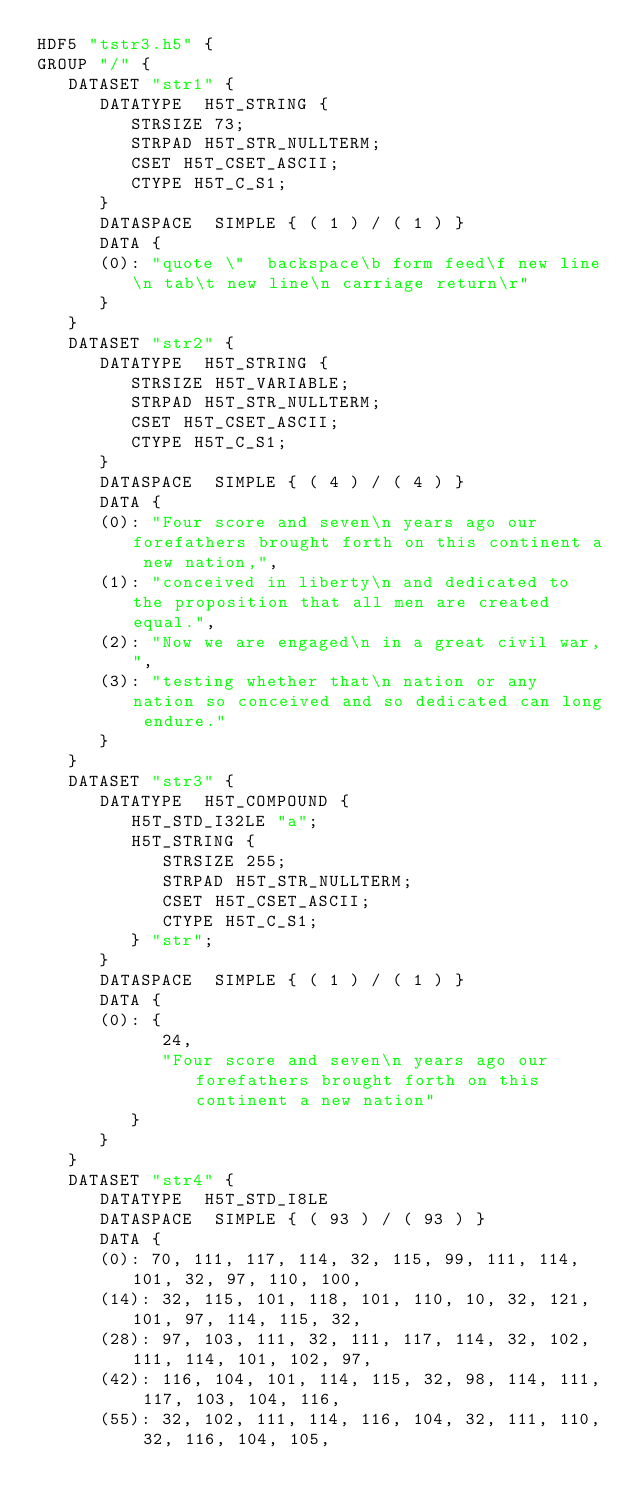Convert code to text. <code><loc_0><loc_0><loc_500><loc_500><_SQL_>HDF5 "tstr3.h5" {
GROUP "/" {
   DATASET "str1" {
      DATATYPE  H5T_STRING {
         STRSIZE 73;
         STRPAD H5T_STR_NULLTERM;
         CSET H5T_CSET_ASCII;
         CTYPE H5T_C_S1;
      }
      DATASPACE  SIMPLE { ( 1 ) / ( 1 ) }
      DATA {
      (0): "quote \"  backspace\b form feed\f new line\n tab\t new line\n carriage return\r"
      }
   }
   DATASET "str2" {
      DATATYPE  H5T_STRING {
         STRSIZE H5T_VARIABLE;
         STRPAD H5T_STR_NULLTERM;
         CSET H5T_CSET_ASCII;
         CTYPE H5T_C_S1;
      }
      DATASPACE  SIMPLE { ( 4 ) / ( 4 ) }
      DATA {
      (0): "Four score and seven\n years ago our forefathers brought forth on this continent a new nation,",
      (1): "conceived in liberty\n and dedicated to the proposition that all men are created equal.",
      (2): "Now we are engaged\n in a great civil war,",
      (3): "testing whether that\n nation or any nation so conceived and so dedicated can long endure."
      }
   }
   DATASET "str3" {
      DATATYPE  H5T_COMPOUND {
         H5T_STD_I32LE "a";
         H5T_STRING {
            STRSIZE 255;
            STRPAD H5T_STR_NULLTERM;
            CSET H5T_CSET_ASCII;
            CTYPE H5T_C_S1;
         } "str";
      }
      DATASPACE  SIMPLE { ( 1 ) / ( 1 ) }
      DATA {
      (0): {
            24,
            "Four score and seven\n years ago our forefathers brought forth on this continent a new nation"
         }
      }
   }
   DATASET "str4" {
      DATATYPE  H5T_STD_I8LE
      DATASPACE  SIMPLE { ( 93 ) / ( 93 ) }
      DATA {
      (0): 70, 111, 117, 114, 32, 115, 99, 111, 114, 101, 32, 97, 110, 100,
      (14): 32, 115, 101, 118, 101, 110, 10, 32, 121, 101, 97, 114, 115, 32,
      (28): 97, 103, 111, 32, 111, 117, 114, 32, 102, 111, 114, 101, 102, 97,
      (42): 116, 104, 101, 114, 115, 32, 98, 114, 111, 117, 103, 104, 116,
      (55): 32, 102, 111, 114, 116, 104, 32, 111, 110, 32, 116, 104, 105,</code> 